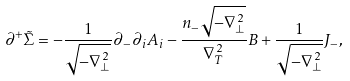<formula> <loc_0><loc_0><loc_500><loc_500>\partial ^ { + } \tilde { \Sigma } = - \frac { 1 } { \sqrt { - { \nabla } _ { \bot } ^ { \, 2 } } } \partial _ { - } \partial _ { i } A _ { i } - \frac { n _ { - } \sqrt { - { \nabla } _ { \bot } ^ { \, 2 } } } { { \nabla } _ { T } ^ { \, 2 } } B + \frac { 1 } { \sqrt { - { \nabla } _ { \bot } ^ { \, 2 } } } J _ { - } ,</formula> 